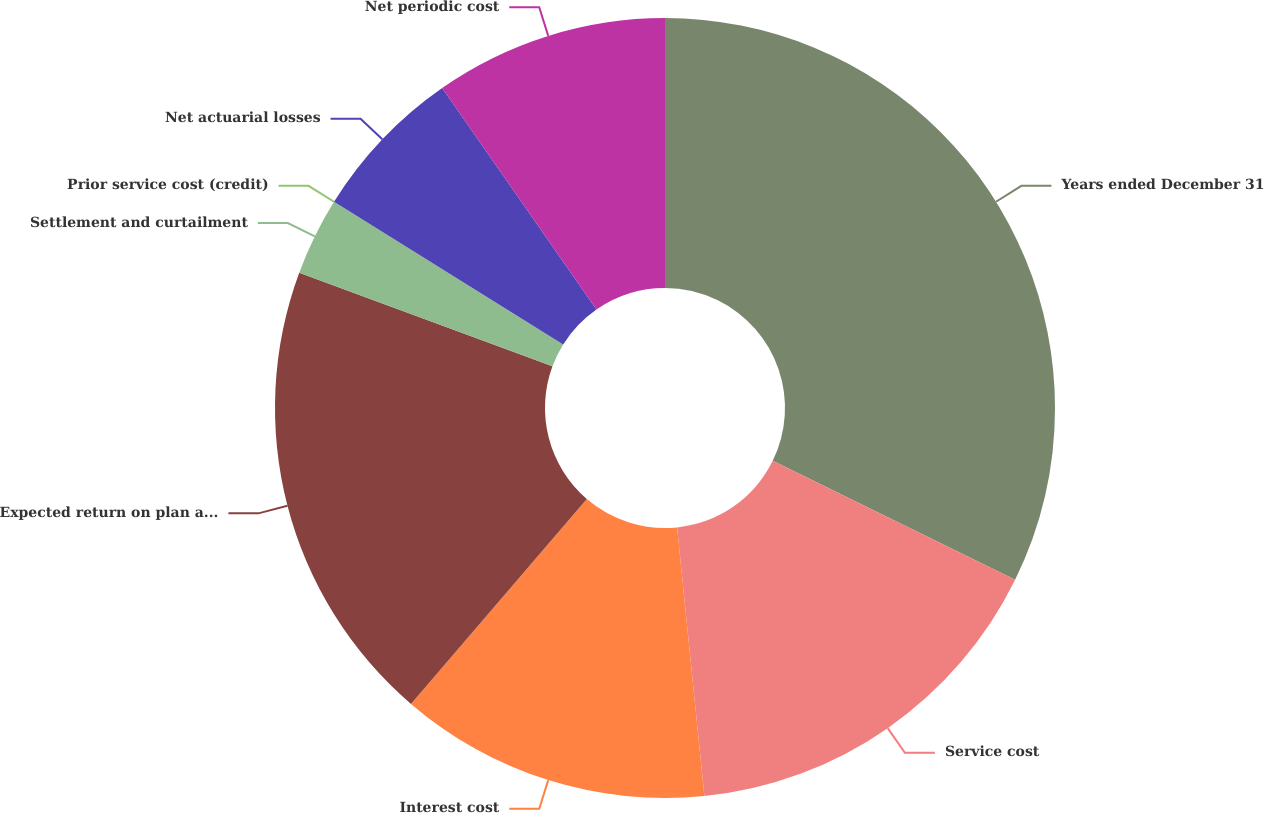Convert chart. <chart><loc_0><loc_0><loc_500><loc_500><pie_chart><fcel>Years ended December 31<fcel>Service cost<fcel>Interest cost<fcel>Expected return on plan assets<fcel>Settlement and curtailment<fcel>Prior service cost (credit)<fcel>Net actuarial losses<fcel>Net periodic cost<nl><fcel>32.26%<fcel>16.13%<fcel>12.9%<fcel>19.35%<fcel>3.23%<fcel>0.0%<fcel>6.45%<fcel>9.68%<nl></chart> 